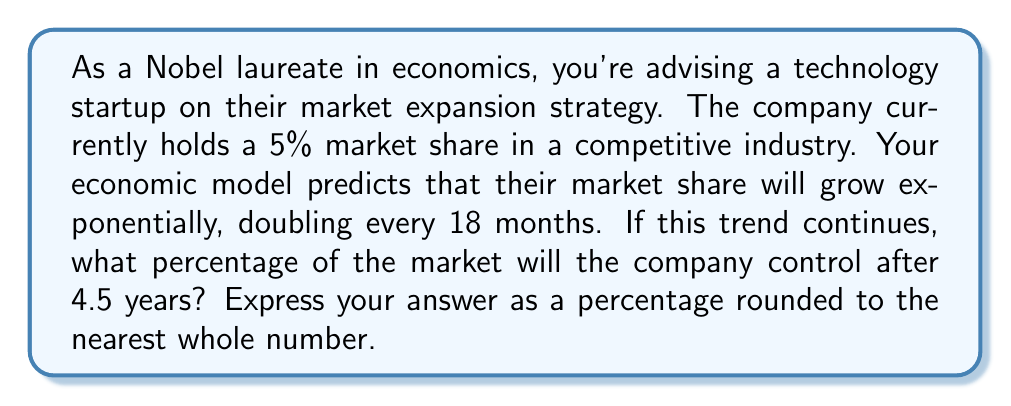What is the answer to this math problem? Let's approach this step-by-step:

1) First, we need to identify our initial value and growth rate:
   - Initial market share: 5%
   - Doubling time: 18 months = 1.5 years

2) We can express this as an exponential function:
   $$ M(t) = 5 \cdot 2^{\frac{t}{1.5}} $$
   where $M(t)$ is the market share after $t$ years.

3) We're asked to find the market share after 4.5 years, so we'll substitute $t = 4.5$:
   $$ M(4.5) = 5 \cdot 2^{\frac{4.5}{1.5}} $$

4) Simplify the exponent:
   $$ M(4.5) = 5 \cdot 2^3 $$

5) Calculate:
   $$ M(4.5) = 5 \cdot 8 = 40 $$

6) Therefore, after 4.5 years, the company will control 40% of the market.

This exponential growth model is common in competitive markets, especially in technology sectors where network effects can lead to rapid expansion. However, it's important to note that in real-world scenarios, growth often slows as a company captures more market share due to increased competition and market saturation.
Answer: 40% 